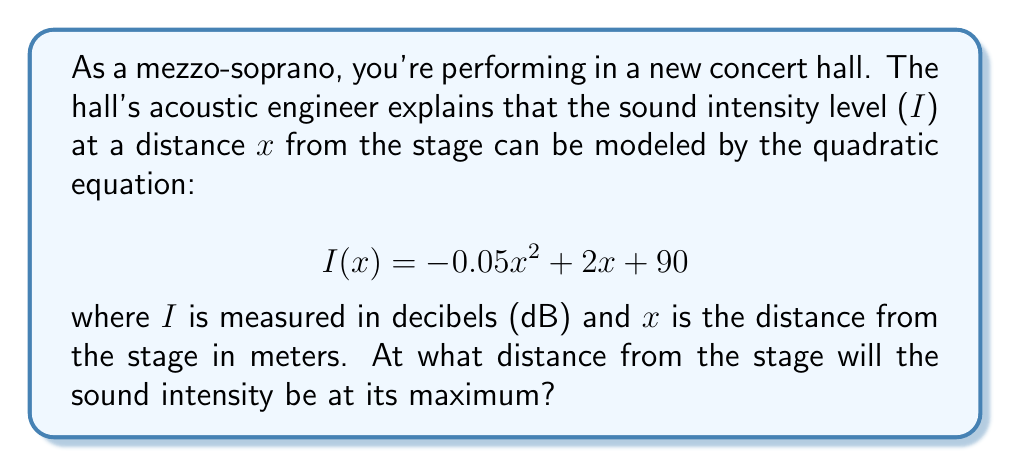Give your solution to this math problem. To find the maximum sound intensity, we need to determine the vertex of the quadratic function. For a quadratic function in the form $f(x) = ax^2 + bx + c$, the x-coordinate of the vertex is given by $x = -\frac{b}{2a}$.

1. Identify the coefficients:
   $a = -0.05$
   $b = 2$
   $c = 90$

2. Apply the formula for the x-coordinate of the vertex:
   $$ x = -\frac{b}{2a} = -\frac{2}{2(-0.05)} = -\frac{2}{-0.1} = 20 $$

3. The x-coordinate of the vertex represents the distance from the stage where the sound intensity is at its maximum.

4. To verify, we can calculate the y-coordinate of the vertex (maximum intensity):
   $$ I(20) = -0.05(20)^2 + 2(20) + 90 = -20 + 40 + 90 = 110 \text{ dB} $$

This confirms that x = 20 meters is indeed the point of maximum intensity.
Answer: 20 meters 